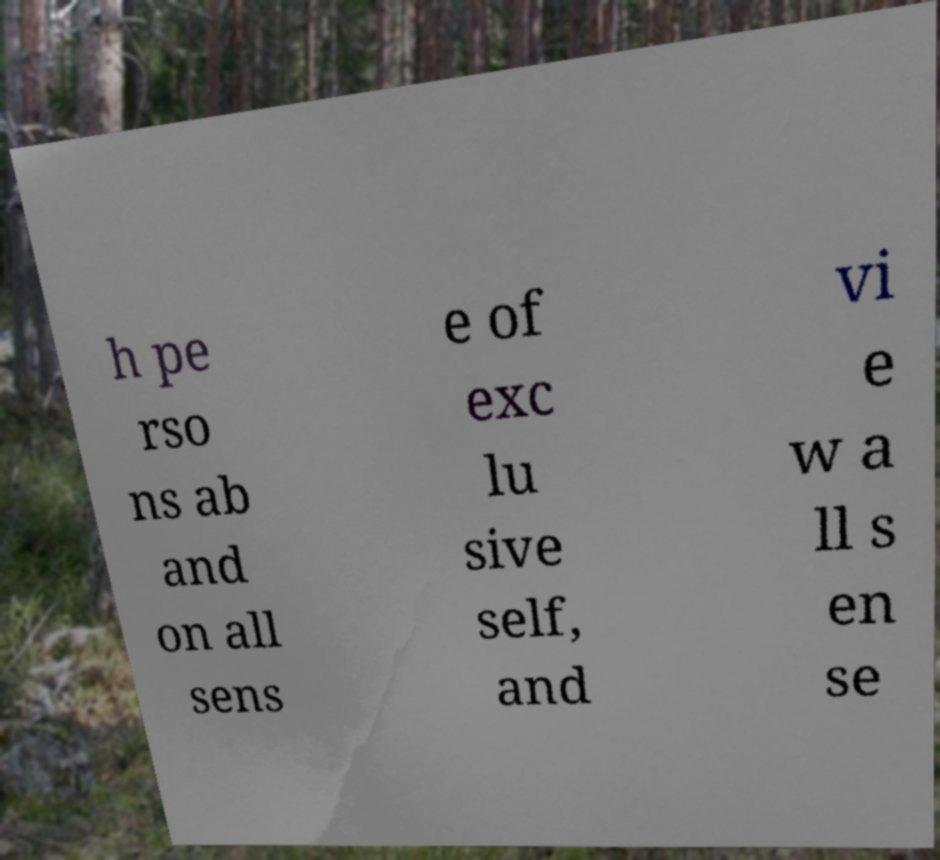Please read and relay the text visible in this image. What does it say? h pe rso ns ab and on all sens e of exc lu sive self, and vi e w a ll s en se 